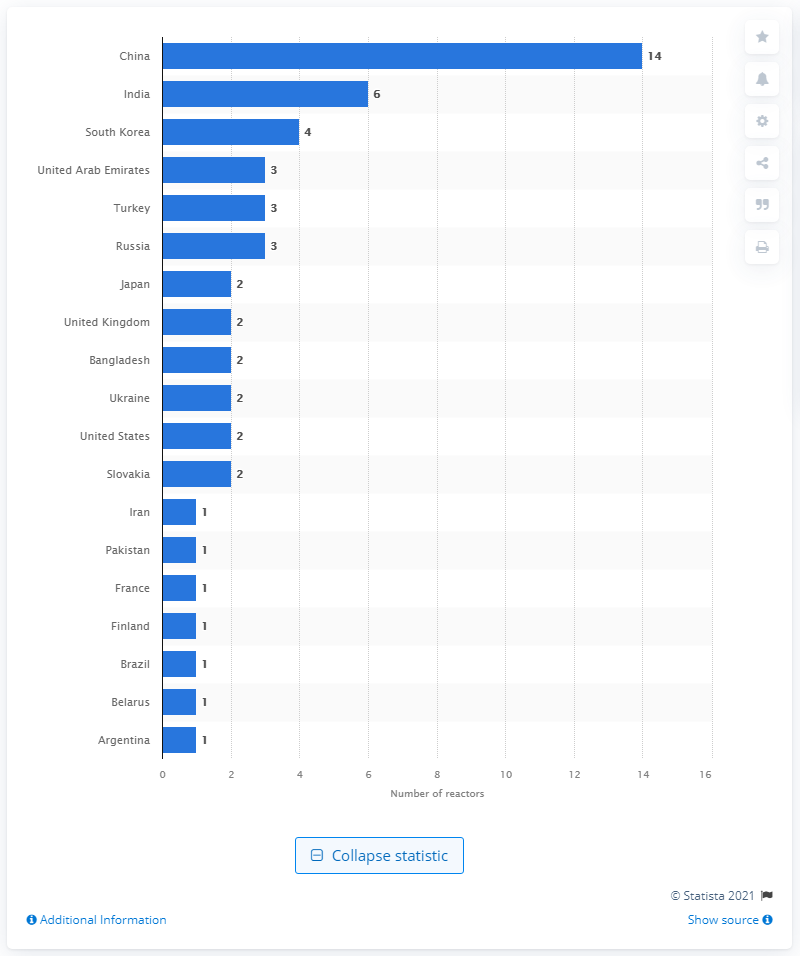Indicate a few pertinent items in this graphic. The majority of nuclear reactors were built in China. 